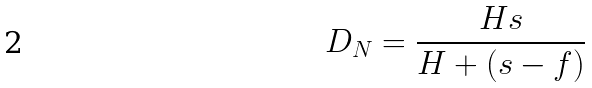Convert formula to latex. <formula><loc_0><loc_0><loc_500><loc_500>D _ { N } = \frac { H s } { H + ( s - f ) }</formula> 